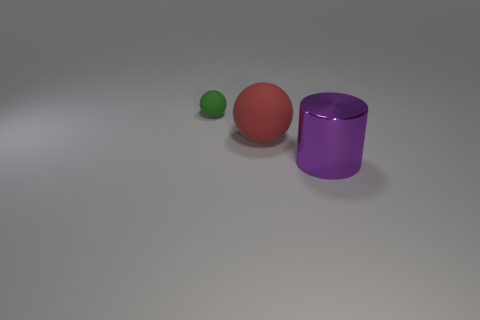How many objects are green cylinders or large things behind the large purple cylinder?
Provide a short and direct response. 1. How many yellow things are either cylinders or large matte things?
Ensure brevity in your answer.  0. There is a big thing that is behind the shiny cylinder right of the small matte sphere; are there any tiny green matte balls that are to the right of it?
Give a very brief answer. No. Is there anything else that has the same size as the cylinder?
Offer a terse response. Yes. Is the small sphere the same color as the cylinder?
Keep it short and to the point. No. What is the color of the matte ball to the left of the big thing that is left of the large purple thing?
Give a very brief answer. Green. What number of small objects are either purple spheres or green spheres?
Offer a very short reply. 1. There is a thing that is on the right side of the tiny green matte sphere and on the left side of the metallic thing; what is its color?
Offer a terse response. Red. Is the material of the large cylinder the same as the tiny ball?
Keep it short and to the point. No. The purple object is what shape?
Keep it short and to the point. Cylinder. 